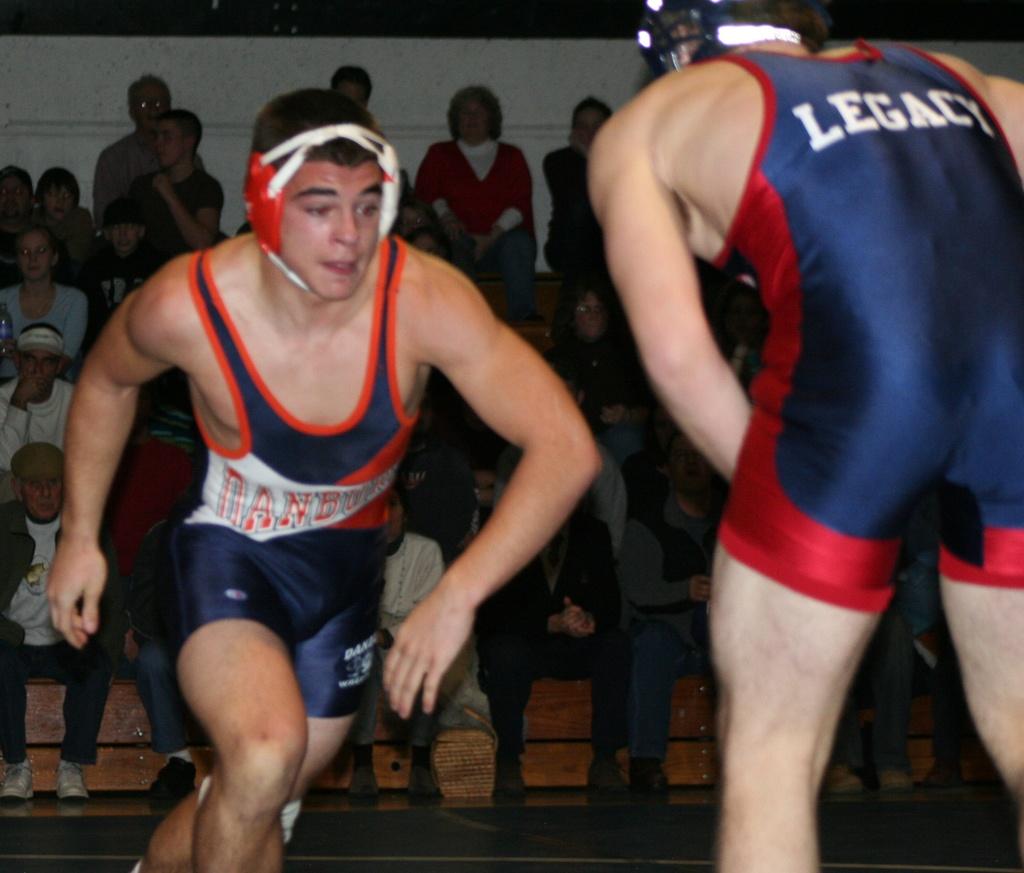What is the team of the guy wearing the dark blue and red outfit?
Your answer should be compact. Legacy. 